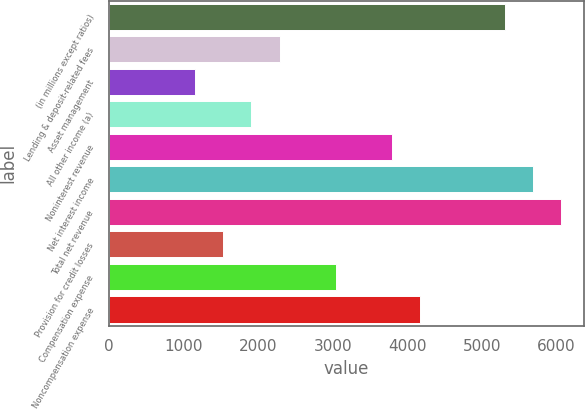Convert chart. <chart><loc_0><loc_0><loc_500><loc_500><bar_chart><fcel>(in millions except ratios)<fcel>Lending & deposit-related fees<fcel>Asset management<fcel>All other income (a)<fcel>Noninterest revenue<fcel>Net interest income<fcel>Total net revenue<fcel>Provision for credit losses<fcel>Compensation expense<fcel>Noncompensation expense<nl><fcel>5312.8<fcel>2287.2<fcel>1152.6<fcel>1909<fcel>3800<fcel>5691<fcel>6069.2<fcel>1530.8<fcel>3043.6<fcel>4178.2<nl></chart> 